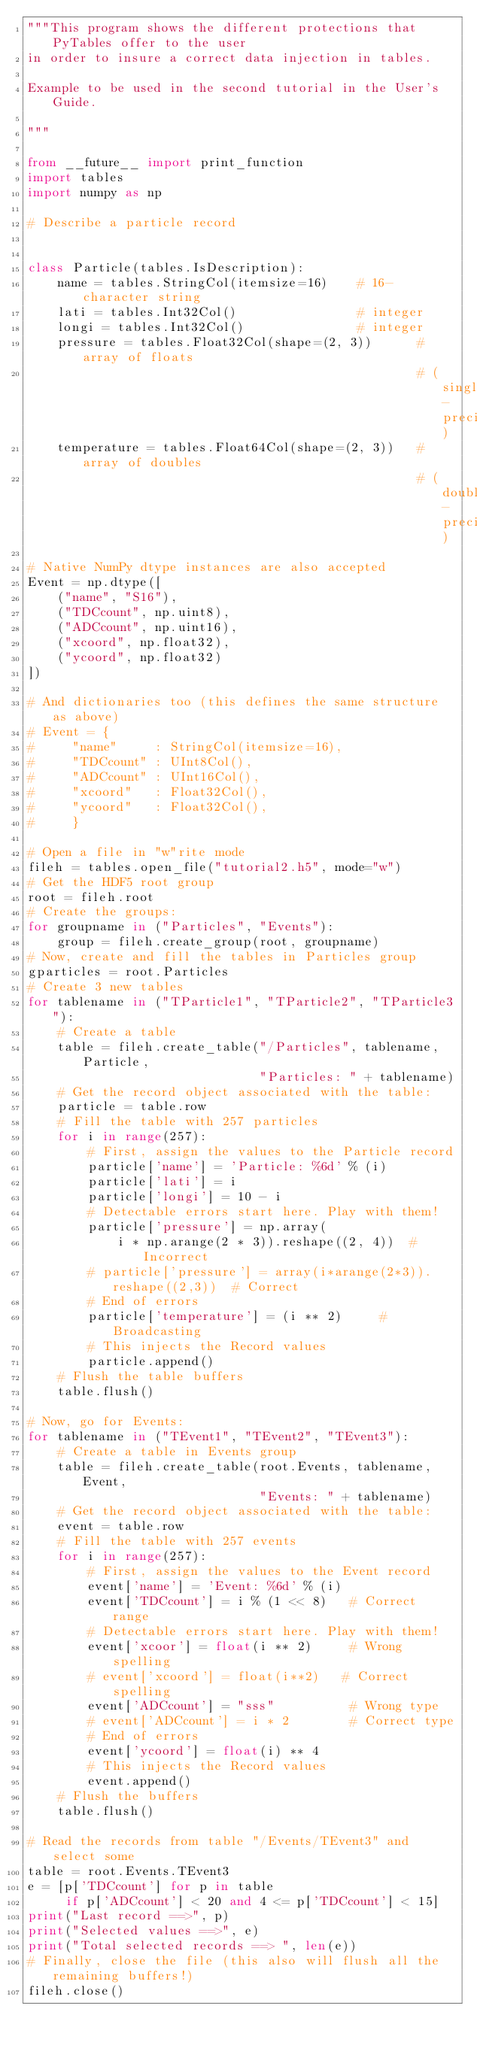Convert code to text. <code><loc_0><loc_0><loc_500><loc_500><_Python_>"""This program shows the different protections that PyTables offer to the user
in order to insure a correct data injection in tables.

Example to be used in the second tutorial in the User's Guide.

"""

from __future__ import print_function
import tables
import numpy as np

# Describe a particle record


class Particle(tables.IsDescription):
    name = tables.StringCol(itemsize=16)    # 16-character string
    lati = tables.Int32Col()                # integer
    longi = tables.Int32Col()               # integer
    pressure = tables.Float32Col(shape=(2, 3))      # array of floats
                                                    # (single-precision)
    temperature = tables.Float64Col(shape=(2, 3))   # array of doubles
                                                    # (double-precision)

# Native NumPy dtype instances are also accepted
Event = np.dtype([
    ("name", "S16"),
    ("TDCcount", np.uint8),
    ("ADCcount", np.uint16),
    ("xcoord", np.float32),
    ("ycoord", np.float32)
])

# And dictionaries too (this defines the same structure as above)
# Event = {
#     "name"     : StringCol(itemsize=16),
#     "TDCcount" : UInt8Col(),
#     "ADCcount" : UInt16Col(),
#     "xcoord"   : Float32Col(),
#     "ycoord"   : Float32Col(),
#     }

# Open a file in "w"rite mode
fileh = tables.open_file("tutorial2.h5", mode="w")
# Get the HDF5 root group
root = fileh.root
# Create the groups:
for groupname in ("Particles", "Events"):
    group = fileh.create_group(root, groupname)
# Now, create and fill the tables in Particles group
gparticles = root.Particles
# Create 3 new tables
for tablename in ("TParticle1", "TParticle2", "TParticle3"):
    # Create a table
    table = fileh.create_table("/Particles", tablename, Particle,
                               "Particles: " + tablename)
    # Get the record object associated with the table:
    particle = table.row
    # Fill the table with 257 particles
    for i in range(257):
        # First, assign the values to the Particle record
        particle['name'] = 'Particle: %6d' % (i)
        particle['lati'] = i
        particle['longi'] = 10 - i
        # Detectable errors start here. Play with them!
        particle['pressure'] = np.array(
            i * np.arange(2 * 3)).reshape((2, 4))  # Incorrect
        # particle['pressure'] = array(i*arange(2*3)).reshape((2,3))  # Correct
        # End of errors
        particle['temperature'] = (i ** 2)     # Broadcasting
        # This injects the Record values
        particle.append()
    # Flush the table buffers
    table.flush()

# Now, go for Events:
for tablename in ("TEvent1", "TEvent2", "TEvent3"):
    # Create a table in Events group
    table = fileh.create_table(root.Events, tablename, Event,
                               "Events: " + tablename)
    # Get the record object associated with the table:
    event = table.row
    # Fill the table with 257 events
    for i in range(257):
        # First, assign the values to the Event record
        event['name'] = 'Event: %6d' % (i)
        event['TDCcount'] = i % (1 << 8)   # Correct range
        # Detectable errors start here. Play with them!
        event['xcoor'] = float(i ** 2)     # Wrong spelling
        # event['xcoord'] = float(i**2)   # Correct spelling
        event['ADCcount'] = "sss"          # Wrong type
        # event['ADCcount'] = i * 2        # Correct type
        # End of errors
        event['ycoord'] = float(i) ** 4
        # This injects the Record values
        event.append()
    # Flush the buffers
    table.flush()

# Read the records from table "/Events/TEvent3" and select some
table = root.Events.TEvent3
e = [p['TDCcount'] for p in table
     if p['ADCcount'] < 20 and 4 <= p['TDCcount'] < 15]
print("Last record ==>", p)
print("Selected values ==>", e)
print("Total selected records ==> ", len(e))
# Finally, close the file (this also will flush all the remaining buffers!)
fileh.close()
</code> 